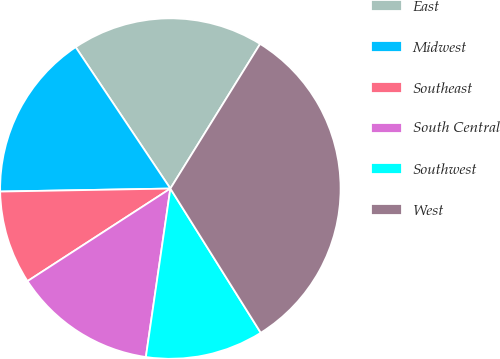Convert chart to OTSL. <chart><loc_0><loc_0><loc_500><loc_500><pie_chart><fcel>East<fcel>Midwest<fcel>Southeast<fcel>South Central<fcel>Southwest<fcel>West<nl><fcel>18.23%<fcel>15.89%<fcel>8.87%<fcel>13.55%<fcel>11.21%<fcel>32.25%<nl></chart> 